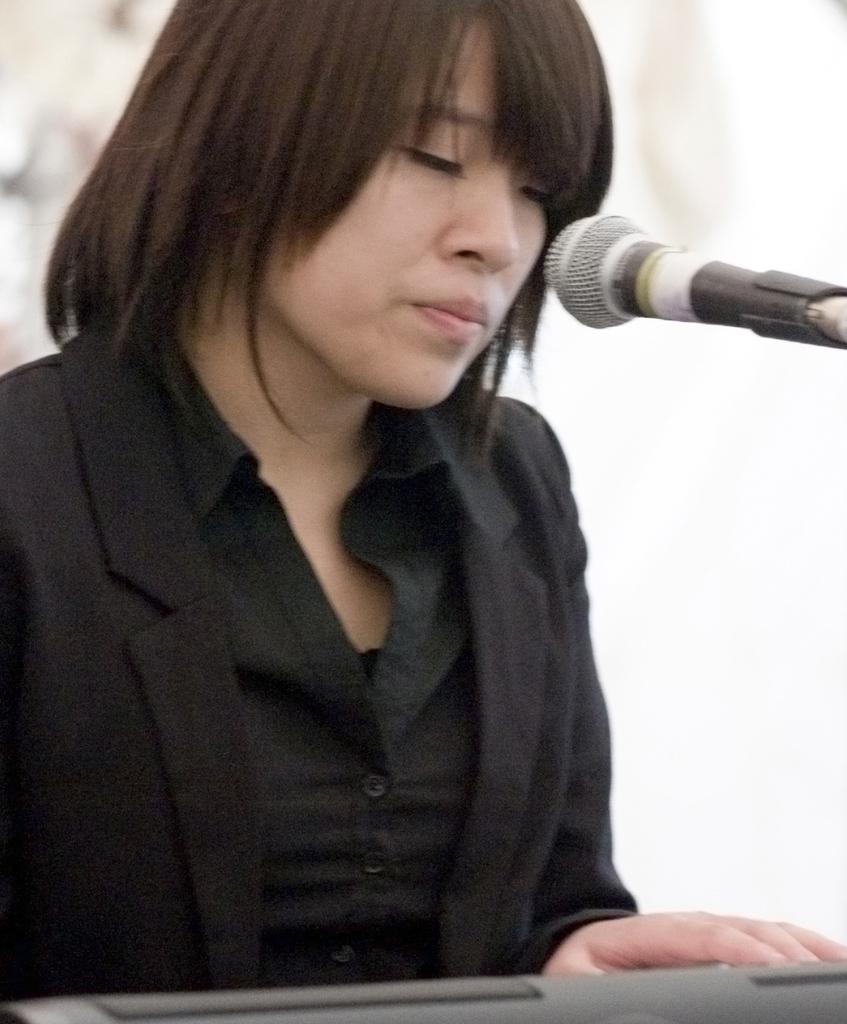Could you give a brief overview of what you see in this image? In this image we can see a lady wearing a black color dress. There is a mic. The background of the image is white in color. 